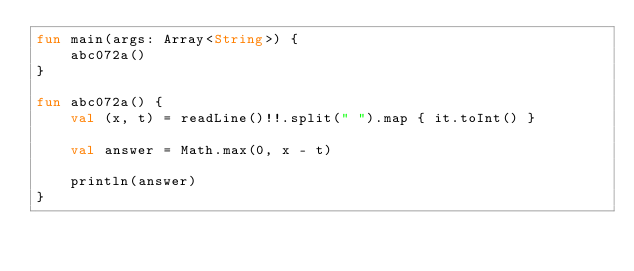<code> <loc_0><loc_0><loc_500><loc_500><_Kotlin_>fun main(args: Array<String>) {
    abc072a()
}

fun abc072a() {
    val (x, t) = readLine()!!.split(" ").map { it.toInt() }

    val answer = Math.max(0, x - t)

    println(answer)
}
</code> 